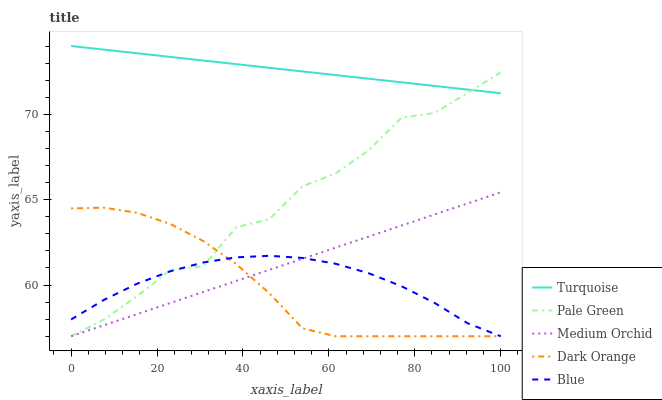Does Dark Orange have the minimum area under the curve?
Answer yes or no. Yes. Does Turquoise have the maximum area under the curve?
Answer yes or no. Yes. Does Turquoise have the minimum area under the curve?
Answer yes or no. No. Does Dark Orange have the maximum area under the curve?
Answer yes or no. No. Is Medium Orchid the smoothest?
Answer yes or no. Yes. Is Pale Green the roughest?
Answer yes or no. Yes. Is Dark Orange the smoothest?
Answer yes or no. No. Is Dark Orange the roughest?
Answer yes or no. No. Does Blue have the lowest value?
Answer yes or no. Yes. Does Turquoise have the lowest value?
Answer yes or no. No. Does Turquoise have the highest value?
Answer yes or no. Yes. Does Dark Orange have the highest value?
Answer yes or no. No. Is Medium Orchid less than Turquoise?
Answer yes or no. Yes. Is Turquoise greater than Medium Orchid?
Answer yes or no. Yes. Does Medium Orchid intersect Dark Orange?
Answer yes or no. Yes. Is Medium Orchid less than Dark Orange?
Answer yes or no. No. Is Medium Orchid greater than Dark Orange?
Answer yes or no. No. Does Medium Orchid intersect Turquoise?
Answer yes or no. No. 